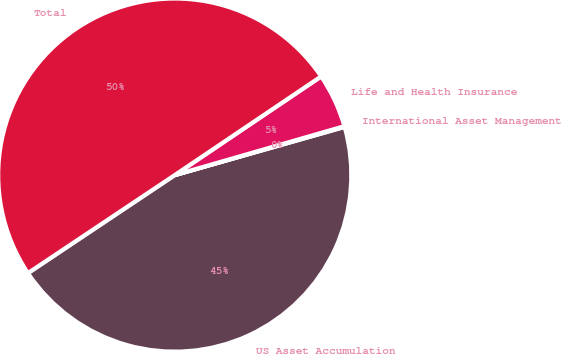Convert chart to OTSL. <chart><loc_0><loc_0><loc_500><loc_500><pie_chart><fcel>US Asset Accumulation<fcel>International Asset Management<fcel>Life and Health Insurance<fcel>Total<nl><fcel>45.03%<fcel>0.07%<fcel>4.97%<fcel>49.93%<nl></chart> 